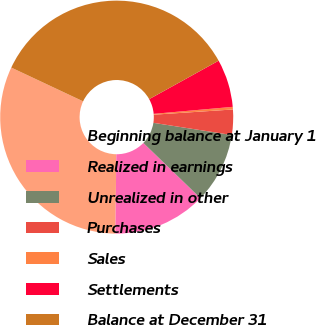Convert chart to OTSL. <chart><loc_0><loc_0><loc_500><loc_500><pie_chart><fcel>Beginning balance at January 1<fcel>Realized in earnings<fcel>Unrealized in other<fcel>Purchases<fcel>Sales<fcel>Settlements<fcel>Balance at December 31<nl><fcel>31.82%<fcel>12.93%<fcel>9.79%<fcel>3.5%<fcel>0.36%<fcel>6.64%<fcel>34.96%<nl></chart> 